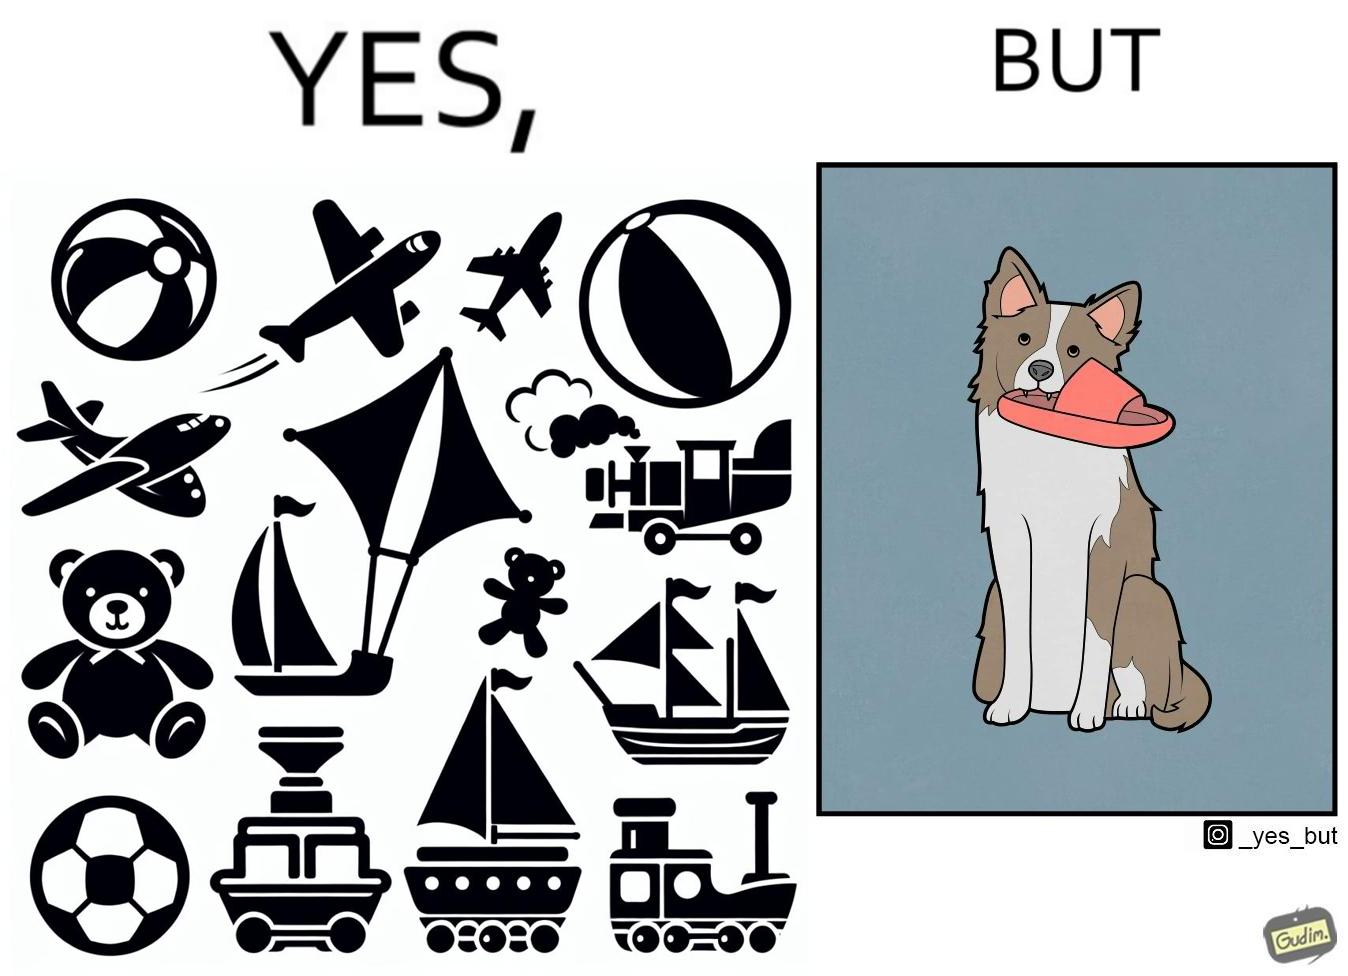Explain the humor or irony in this image. The image is ironical, as even though the dog owner has bought toys for the dog, the dog is playing with a slipper in its mouth. 